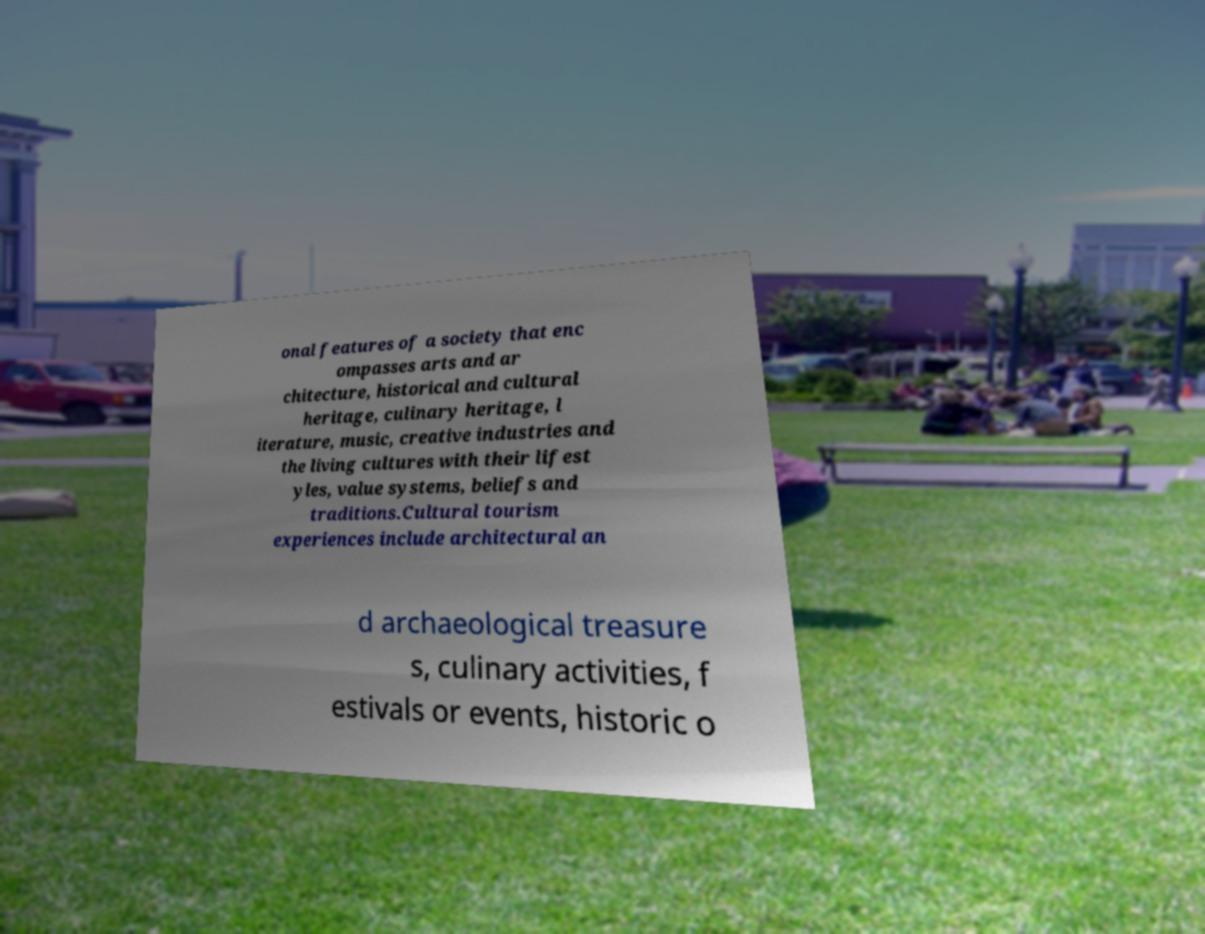Please identify and transcribe the text found in this image. onal features of a society that enc ompasses arts and ar chitecture, historical and cultural heritage, culinary heritage, l iterature, music, creative industries and the living cultures with their lifest yles, value systems, beliefs and traditions.Cultural tourism experiences include architectural an d archaeological treasure s, culinary activities, f estivals or events, historic o 